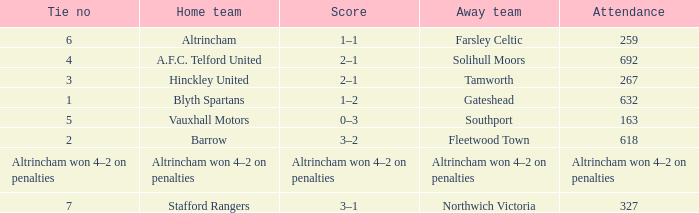What was the attendance for the away team Solihull Moors? 692.0. 